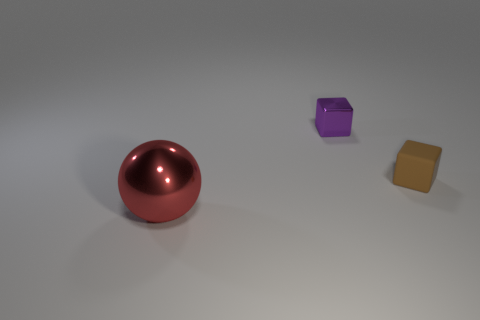Is there any other thing that is the same size as the ball?
Offer a terse response. No. What shape is the object on the left side of the small object behind the tiny brown object?
Keep it short and to the point. Sphere. Are there any big balls behind the big object?
Your answer should be compact. No. There is a shiny thing that is the same size as the brown block; what is its color?
Make the answer very short. Purple. What number of purple objects have the same material as the red object?
Keep it short and to the point. 1. How many other things are the same size as the red metallic thing?
Offer a very short reply. 0. Is there a purple metal cube that has the same size as the purple shiny thing?
Keep it short and to the point. No. Does the metallic object that is on the right side of the large red shiny object have the same color as the small rubber block?
Ensure brevity in your answer.  No. What number of objects are either small shiny cubes or gray metallic balls?
Provide a short and direct response. 1. There is a metallic object that is left of the purple metallic cube; is its size the same as the small rubber object?
Provide a succinct answer. No. 